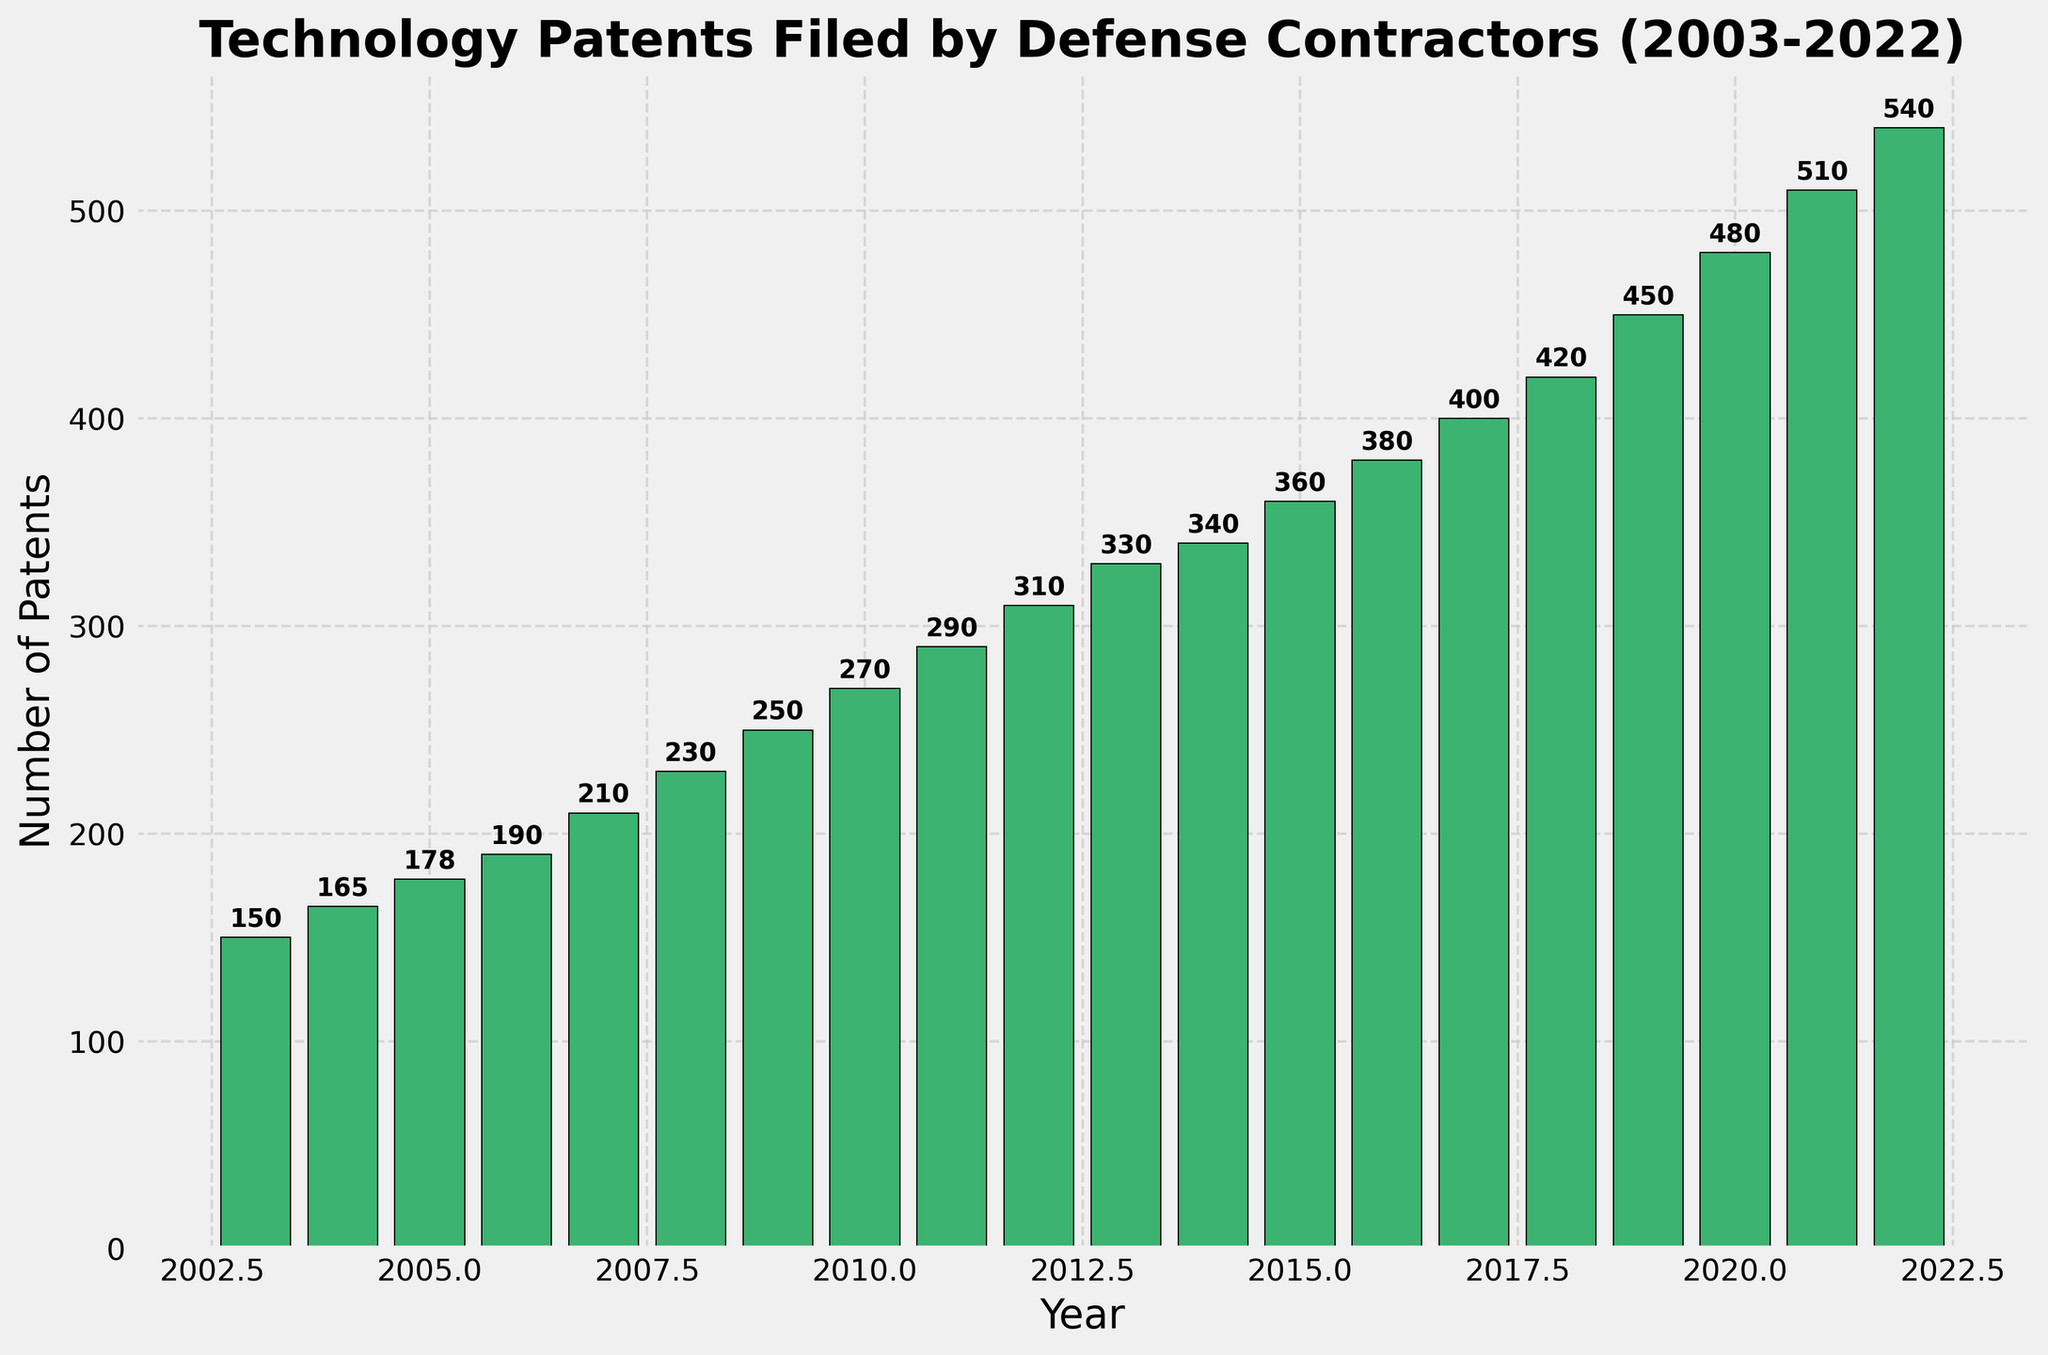How many technology patents were filed in 2010? Look at the bar corresponding to the year 2010 and read the height of the bar. The number above the bar is 270, indicating 270 patents.
Answer: 270 What was the trend in the number of patents filed from 2003 to 2022? Observe whether the height of the bars increases, decreases, or remains the same. The bars consistently increase in height each year, indicating an increasing trend in the number of patents filed.
Answer: Increasing What's the difference in the number of technology patents filed between 2010 and 2020? Find the heights of the bars for 2010 and 2020, which are 270 and 480 respectively. Subtract the 2010 value from the 2020 value: 480 - 270 = 210.
Answer: 210 During which year did the number of technology patents filed first exceed 400? Locate the first bar that exceeds 400. The bar for 2017 is labeled with 400, so the first year it exceeds 400 is 2017.
Answer: 2017 Which year had the highest number of technology patents filed, and what was the number? Identify the tallest bar and read the number above it. The tallest bar corresponds to 2022 with 540 patents filed.
Answer: 2022, 540 What was the average number of technology patents filed per year from 2003 to 2022? Sum all the patent numbers and divide by the number of years (20). The sum is 6753 patents. Thus, 6753 / 20 = 337.65, approximating to 338.
Answer: 338 Compare the number of patents filed in 2015 to 2020. Which year had more patents filed and by how much? Look at the bars for 2015 and 2020. 2015 had 360 patents, and 2020 had 480 patents. Subtract the 2015 value from the 2020 value: 480 - 360 = 120. 2020 had more patents filed.
Answer: 2020, 120 By what percentage did the number of technology patents filed increase from 2009 to 2019? Identify the patent numbers for 2009 and 2019 (250 and 450, respectively). Calculate the percentage increase: ((450 - 250) / 250) * 100 = 80%.
Answer: 80% Which years showed an equal number of technology patents filed? Look for bars with identical heights. The bar labels show that no two years had the exact same number of technology patents filed.
Answer: None What is the median number of technology patents filed over the years 2003 to 2022? List all patent values (150, 165, 178, 190, 210, 230, 250, 270, 290, 310, 330, 340, 360, 380, 400, 420, 450, 480, 510, 540), arrange in ascending order, and find the middle value. The median here is the average of the 10th and 11th values (310 and 330): (310 + 330) / 2 = 320.
Answer: 320 